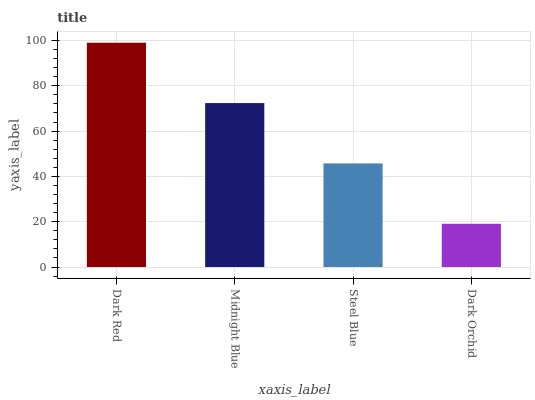Is Dark Orchid the minimum?
Answer yes or no. Yes. Is Dark Red the maximum?
Answer yes or no. Yes. Is Midnight Blue the minimum?
Answer yes or no. No. Is Midnight Blue the maximum?
Answer yes or no. No. Is Dark Red greater than Midnight Blue?
Answer yes or no. Yes. Is Midnight Blue less than Dark Red?
Answer yes or no. Yes. Is Midnight Blue greater than Dark Red?
Answer yes or no. No. Is Dark Red less than Midnight Blue?
Answer yes or no. No. Is Midnight Blue the high median?
Answer yes or no. Yes. Is Steel Blue the low median?
Answer yes or no. Yes. Is Dark Orchid the high median?
Answer yes or no. No. Is Dark Red the low median?
Answer yes or no. No. 